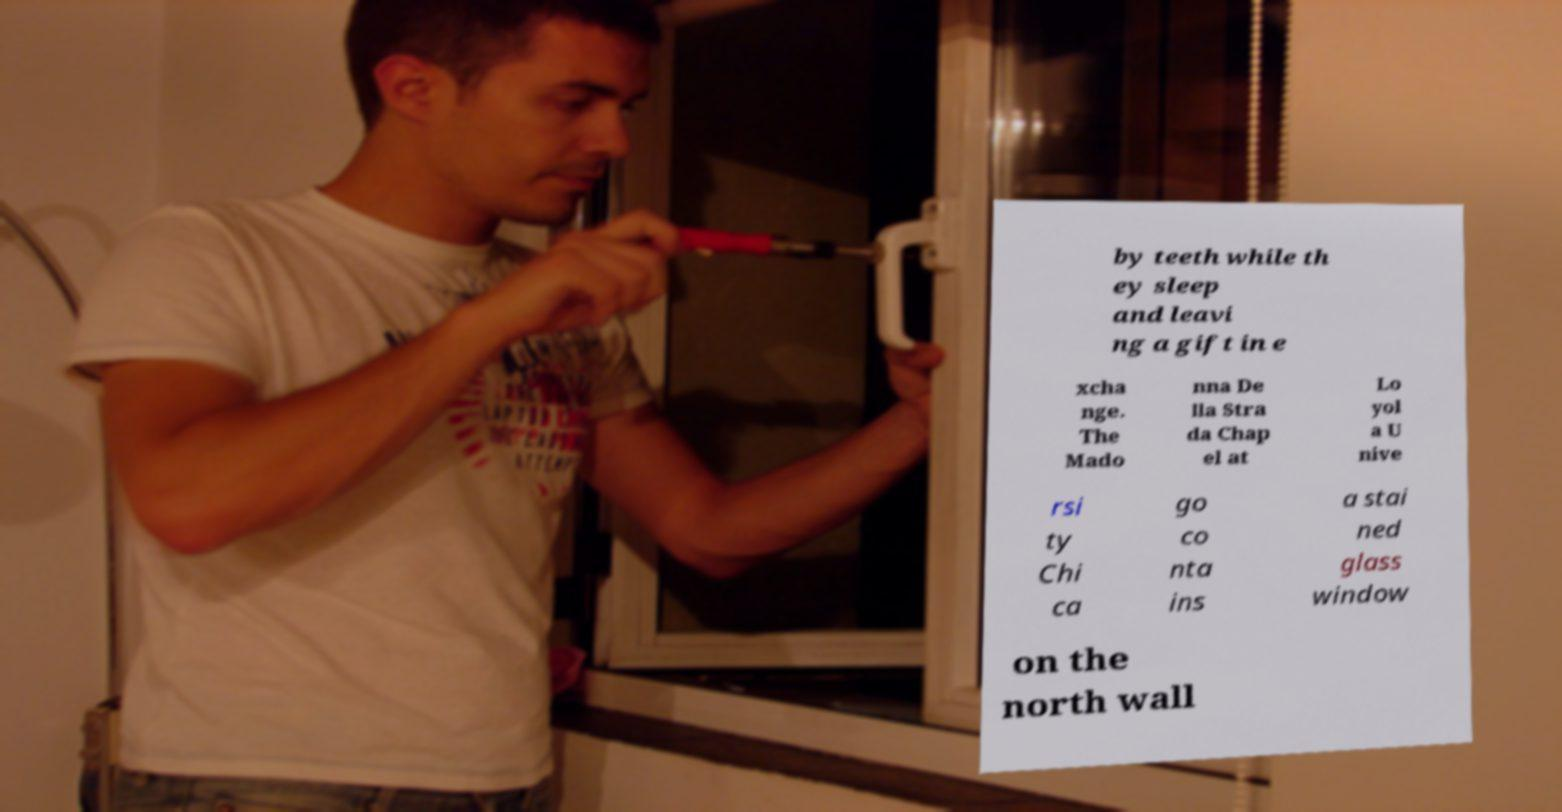Can you read and provide the text displayed in the image?This photo seems to have some interesting text. Can you extract and type it out for me? by teeth while th ey sleep and leavi ng a gift in e xcha nge. The Mado nna De lla Stra da Chap el at Lo yol a U nive rsi ty Chi ca go co nta ins a stai ned glass window on the north wall 